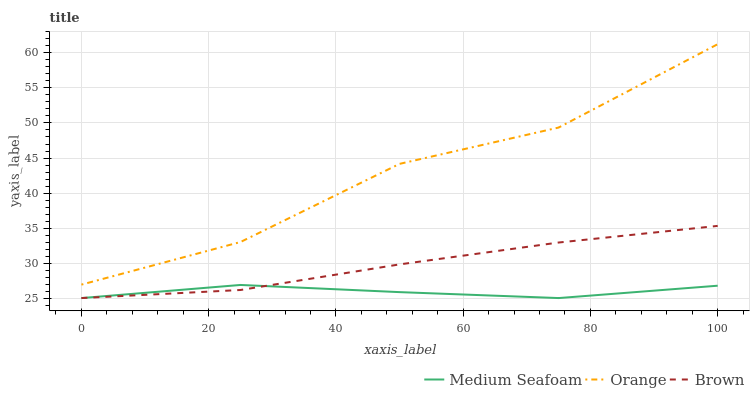Does Medium Seafoam have the minimum area under the curve?
Answer yes or no. Yes. Does Orange have the maximum area under the curve?
Answer yes or no. Yes. Does Brown have the minimum area under the curve?
Answer yes or no. No. Does Brown have the maximum area under the curve?
Answer yes or no. No. Is Brown the smoothest?
Answer yes or no. Yes. Is Orange the roughest?
Answer yes or no. Yes. Is Medium Seafoam the smoothest?
Answer yes or no. No. Is Medium Seafoam the roughest?
Answer yes or no. No. Does Brown have the lowest value?
Answer yes or no. Yes. Does Orange have the highest value?
Answer yes or no. Yes. Does Brown have the highest value?
Answer yes or no. No. Is Medium Seafoam less than Orange?
Answer yes or no. Yes. Is Orange greater than Brown?
Answer yes or no. Yes. Does Medium Seafoam intersect Brown?
Answer yes or no. Yes. Is Medium Seafoam less than Brown?
Answer yes or no. No. Is Medium Seafoam greater than Brown?
Answer yes or no. No. Does Medium Seafoam intersect Orange?
Answer yes or no. No. 